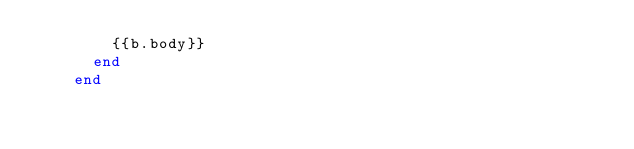Convert code to text. <code><loc_0><loc_0><loc_500><loc_500><_Crystal_>        {{b.body}}
      end
    end
</code> 